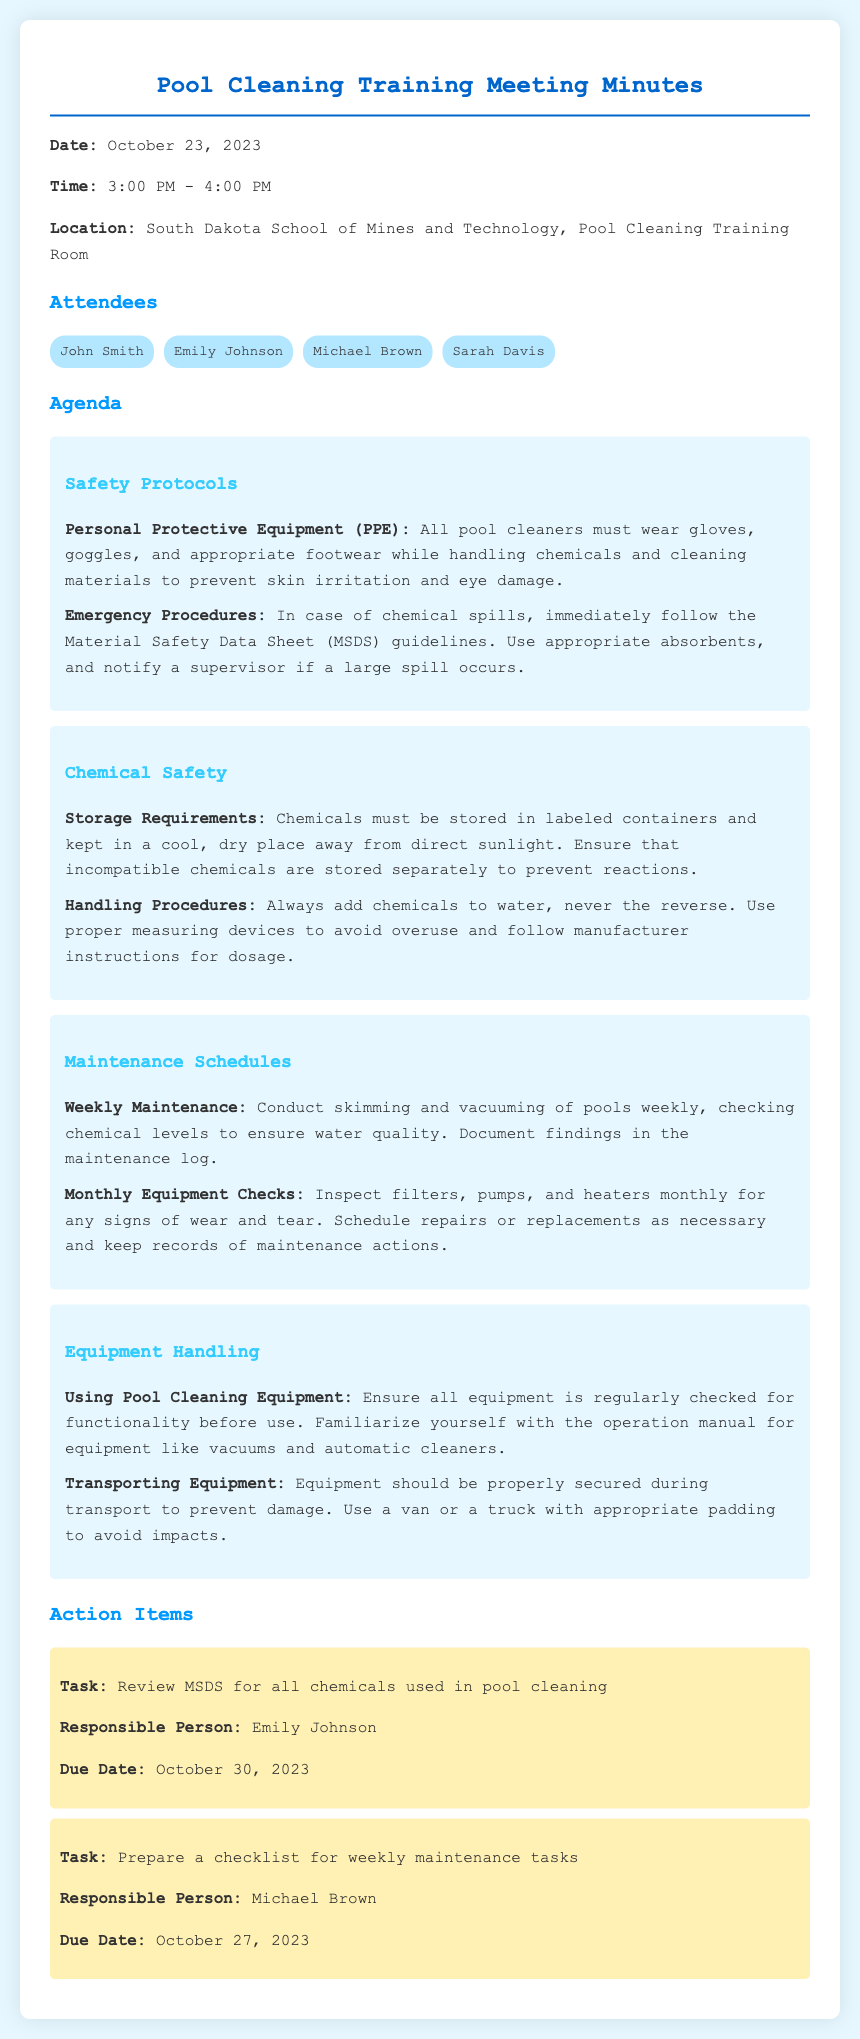what date was the meeting held? The date of the meeting is specified in the document as October 23, 2023.
Answer: October 23, 2023 who is responsible for reviewing MSDS for all chemicals? The document lists Emily Johnson as the responsible person for this task.
Answer: Emily Johnson what type of PPE is required? The document outlines that all pool cleaners must wear gloves, goggles, and appropriate footwear.
Answer: gloves, goggles, and appropriate footwear how often should equipment checks be performed? The document states that equipment checks should be conducted monthly.
Answer: monthly what should be done in case of a chemical spill? The meeting minutes indicate that the Material Safety Data Sheet (MSDS) guidelines must be followed for chemical spills.
Answer: follow MSDS guidelines which task is due on October 27, 2023? The document specifies that preparing a checklist for weekly maintenance tasks is due on this date.
Answer: prepare a checklist for weekly maintenance tasks what is the weekly maintenance task mentioned? The document mentions that skimming and vacuuming of pools is a weekly maintenance task.
Answer: skimming and vacuuming of pools what should be familiarized before using pool cleaning equipment? The meeting notes suggest familiarizing oneself with the operation manual for equipment like vacuums and automatic cleaners.
Answer: operation manual 